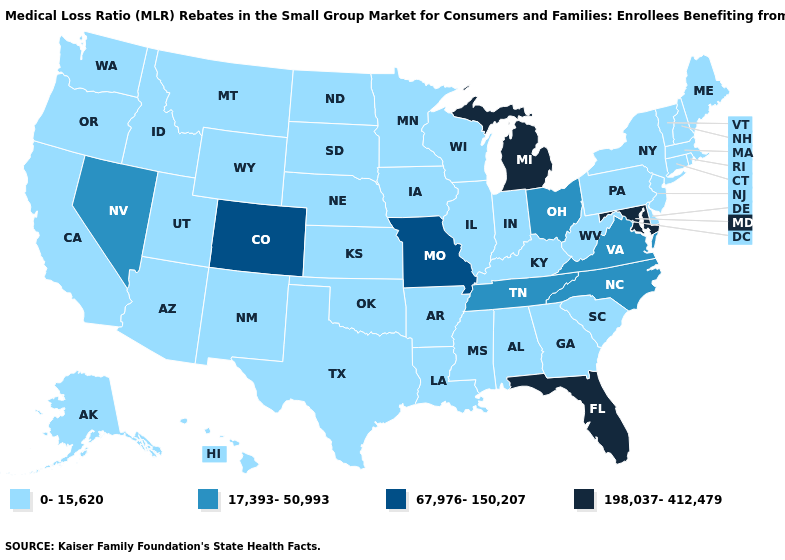Name the states that have a value in the range 198,037-412,479?
Be succinct. Florida, Maryland, Michigan. Which states have the lowest value in the Northeast?
Write a very short answer. Connecticut, Maine, Massachusetts, New Hampshire, New Jersey, New York, Pennsylvania, Rhode Island, Vermont. Name the states that have a value in the range 198,037-412,479?
Concise answer only. Florida, Maryland, Michigan. Name the states that have a value in the range 17,393-50,993?
Concise answer only. Nevada, North Carolina, Ohio, Tennessee, Virginia. Name the states that have a value in the range 198,037-412,479?
Be succinct. Florida, Maryland, Michigan. What is the value of North Carolina?
Quick response, please. 17,393-50,993. How many symbols are there in the legend?
Be succinct. 4. What is the value of New Hampshire?
Short answer required. 0-15,620. Does Nebraska have the highest value in the MidWest?
Concise answer only. No. Is the legend a continuous bar?
Quick response, please. No. Does Vermont have the same value as Michigan?
Short answer required. No. 